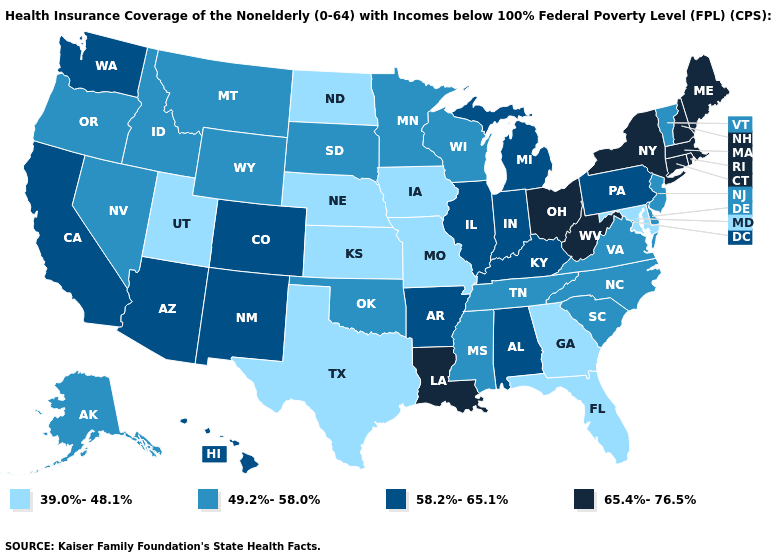Name the states that have a value in the range 65.4%-76.5%?
Quick response, please. Connecticut, Louisiana, Maine, Massachusetts, New Hampshire, New York, Ohio, Rhode Island, West Virginia. What is the value of Mississippi?
Be succinct. 49.2%-58.0%. Name the states that have a value in the range 49.2%-58.0%?
Answer briefly. Alaska, Delaware, Idaho, Minnesota, Mississippi, Montana, Nevada, New Jersey, North Carolina, Oklahoma, Oregon, South Carolina, South Dakota, Tennessee, Vermont, Virginia, Wisconsin, Wyoming. What is the value of Colorado?
Quick response, please. 58.2%-65.1%. What is the value of Maine?
Answer briefly. 65.4%-76.5%. What is the value of New Mexico?
Be succinct. 58.2%-65.1%. What is the highest value in states that border Missouri?
Write a very short answer. 58.2%-65.1%. How many symbols are there in the legend?
Concise answer only. 4. What is the highest value in states that border Connecticut?
Be succinct. 65.4%-76.5%. Which states have the lowest value in the MidWest?
Quick response, please. Iowa, Kansas, Missouri, Nebraska, North Dakota. Does Alabama have the same value as Nevada?
Short answer required. No. How many symbols are there in the legend?
Give a very brief answer. 4. Name the states that have a value in the range 58.2%-65.1%?
Answer briefly. Alabama, Arizona, Arkansas, California, Colorado, Hawaii, Illinois, Indiana, Kentucky, Michigan, New Mexico, Pennsylvania, Washington. Does the map have missing data?
Concise answer only. No. What is the value of North Dakota?
Keep it brief. 39.0%-48.1%. 